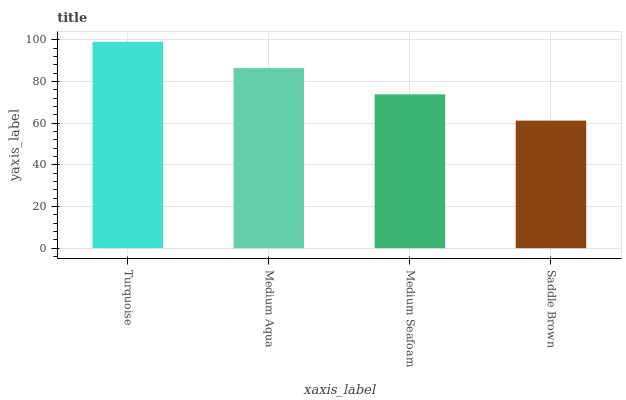Is Saddle Brown the minimum?
Answer yes or no. Yes. Is Turquoise the maximum?
Answer yes or no. Yes. Is Medium Aqua the minimum?
Answer yes or no. No. Is Medium Aqua the maximum?
Answer yes or no. No. Is Turquoise greater than Medium Aqua?
Answer yes or no. Yes. Is Medium Aqua less than Turquoise?
Answer yes or no. Yes. Is Medium Aqua greater than Turquoise?
Answer yes or no. No. Is Turquoise less than Medium Aqua?
Answer yes or no. No. Is Medium Aqua the high median?
Answer yes or no. Yes. Is Medium Seafoam the low median?
Answer yes or no. Yes. Is Turquoise the high median?
Answer yes or no. No. Is Saddle Brown the low median?
Answer yes or no. No. 